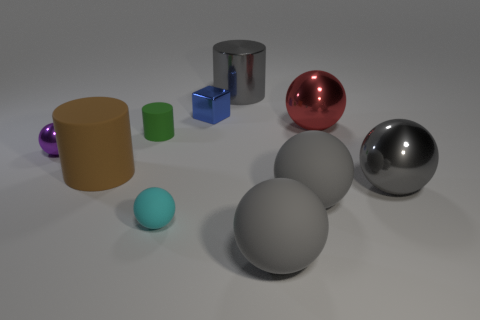Is there a metal cylinder that has the same size as the red sphere?
Give a very brief answer. Yes. Is the color of the large shiny ball to the right of the large red metal sphere the same as the large cylinder that is right of the brown thing?
Provide a succinct answer. Yes. How many matte objects are blue objects or tiny cyan things?
Provide a short and direct response. 1. There is a gray shiny thing on the left side of the large gray matte ball that is in front of the small cyan matte object; what number of big red shiny spheres are behind it?
Your response must be concise. 0. What is the size of the gray sphere that is made of the same material as the small blue block?
Offer a very short reply. Large. How many metal balls are the same color as the shiny cylinder?
Ensure brevity in your answer.  1. There is a rubber sphere that is in front of the cyan rubber thing; does it have the same size as the large gray shiny cylinder?
Give a very brief answer. Yes. What color is the large thing that is both to the left of the red object and behind the small green thing?
Ensure brevity in your answer.  Gray. What number of things are either gray rubber objects or big gray metallic things that are in front of the tiny blue thing?
Make the answer very short. 3. What material is the big cylinder that is behind the small green object on the left side of the red sphere that is right of the green matte thing made of?
Offer a terse response. Metal. 